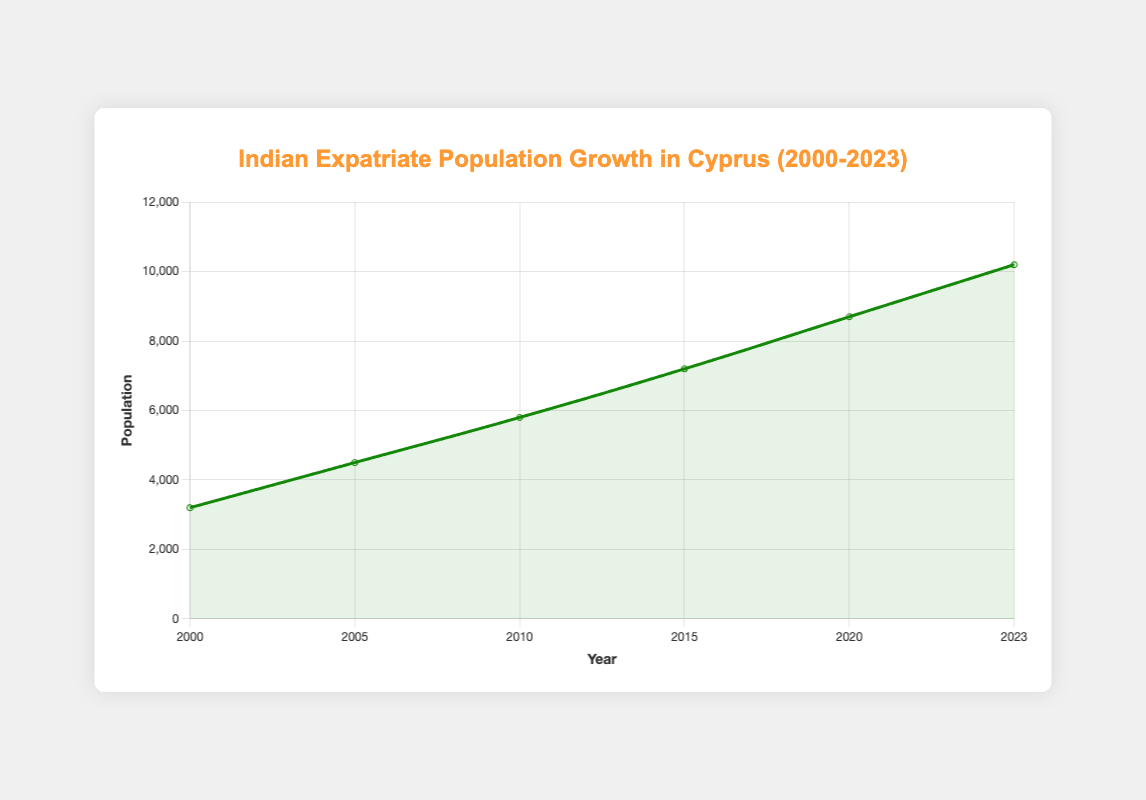What is the total population growth from 2000 to 2023? Sum up the population values for each year and determine the difference between 2000 and 2023. Population in 2000 is 3200, and in 2023, it is 10200. Thus, growth = 10200 - 3200 = 7000
Answer: 7000 Which year saw the highest population of Indian expatriates in Cyprus? Look for the year with the highest population value in the dataset. The population in 2023 is the highest at 10200
Answer: 2023 What is the average population of Indian expatriates over the given years? Sum up the population values and divide by the number of years (6). Total = 3200 + 4500 + 5800 + 7200 + 8700 + 10200 = 39600. Average = 39600 / 6 = 6600
Answer: 6600 In which years did the population increase by 1500 or more people compared to the previous data point? Calculate the increases between consecutive years. Check: 4500 - 3200 = 1300, 5800 - 4500 = 1300, 7200 - 5800 = 1400, 8700 - 7200 = 1500, 10200 - 8700 = 1500. Thus, 2020 and 2023 both saw an increase of 1500
Answer: 2020, 2023 Compare the population in 2000 and 2010. Which was larger and by how much? Compare the population values for the two years: Population in 2000 is 3200 and in 2010 is 5800. Difference = 5800 - 3200 = 2600
Answer: 2010 by 2600 How many main cities were included in the dataset by 2020? Identify the main cities in 2020 from the dataset. They are Nicosia, Limassol, Larnaca, Paphos, and Famagusta, making a total of 5 cities
Answer: 5 By how much did the child population increase from 2000 to 2023? Child population in 2000 is 800 and in 2023 is 2400. The increase is 2400 - 800 = 1600
Answer: 1600 Which year had an equal gender ratio of male and female population? Check the gender ratio for each year and identify where the males and females are equal. In 2000, both were 1600
Answer: 2000 What is the percentage growth in population from 2015 to 2023? Calculate the growth percentage: Population in 2015 is 7200, and in 2023, it's 10200. Growth = 10200 - 7200 = 3000. Percentage growth = (3000/7200) * 100 ≈ 41.67%
Answer: ~41.67% Which age group saw the least growth in population from 2000 to 2023? Compare the numbers for children, adults, and seniors in 2000 and 2023. Growth for children: 2400 - 800 = 1600, for adults: 6100 - 2000 = 4100, for seniors: 1700 - 400 = 1300. Seniors saw the least growth of 1300
Answer: Seniors 